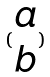<formula> <loc_0><loc_0><loc_500><loc_500>( \begin{matrix} a \\ b \end{matrix} )</formula> 